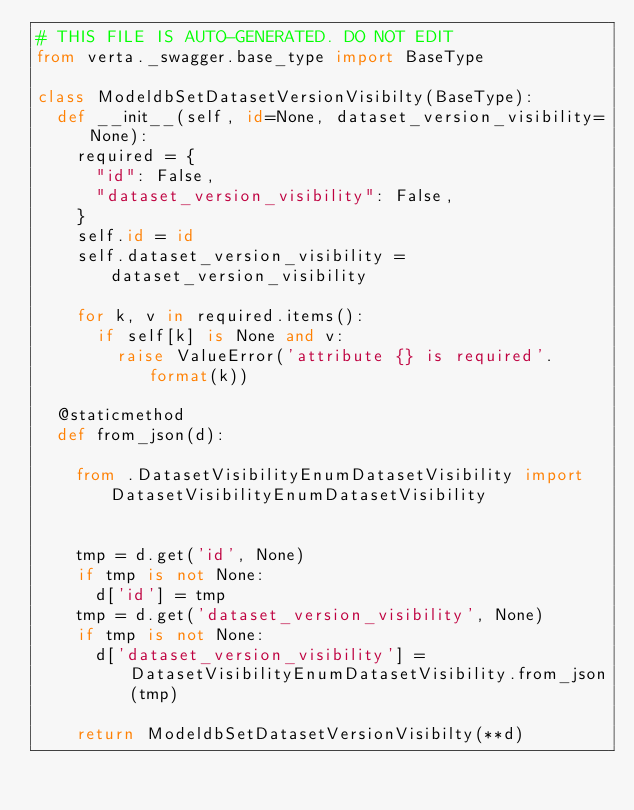Convert code to text. <code><loc_0><loc_0><loc_500><loc_500><_Python_># THIS FILE IS AUTO-GENERATED. DO NOT EDIT
from verta._swagger.base_type import BaseType

class ModeldbSetDatasetVersionVisibilty(BaseType):
  def __init__(self, id=None, dataset_version_visibility=None):
    required = {
      "id": False,
      "dataset_version_visibility": False,
    }
    self.id = id
    self.dataset_version_visibility = dataset_version_visibility

    for k, v in required.items():
      if self[k] is None and v:
        raise ValueError('attribute {} is required'.format(k))

  @staticmethod
  def from_json(d):
    
    from .DatasetVisibilityEnumDatasetVisibility import DatasetVisibilityEnumDatasetVisibility


    tmp = d.get('id', None)
    if tmp is not None:
      d['id'] = tmp
    tmp = d.get('dataset_version_visibility', None)
    if tmp is not None:
      d['dataset_version_visibility'] = DatasetVisibilityEnumDatasetVisibility.from_json(tmp)

    return ModeldbSetDatasetVersionVisibilty(**d)
</code> 